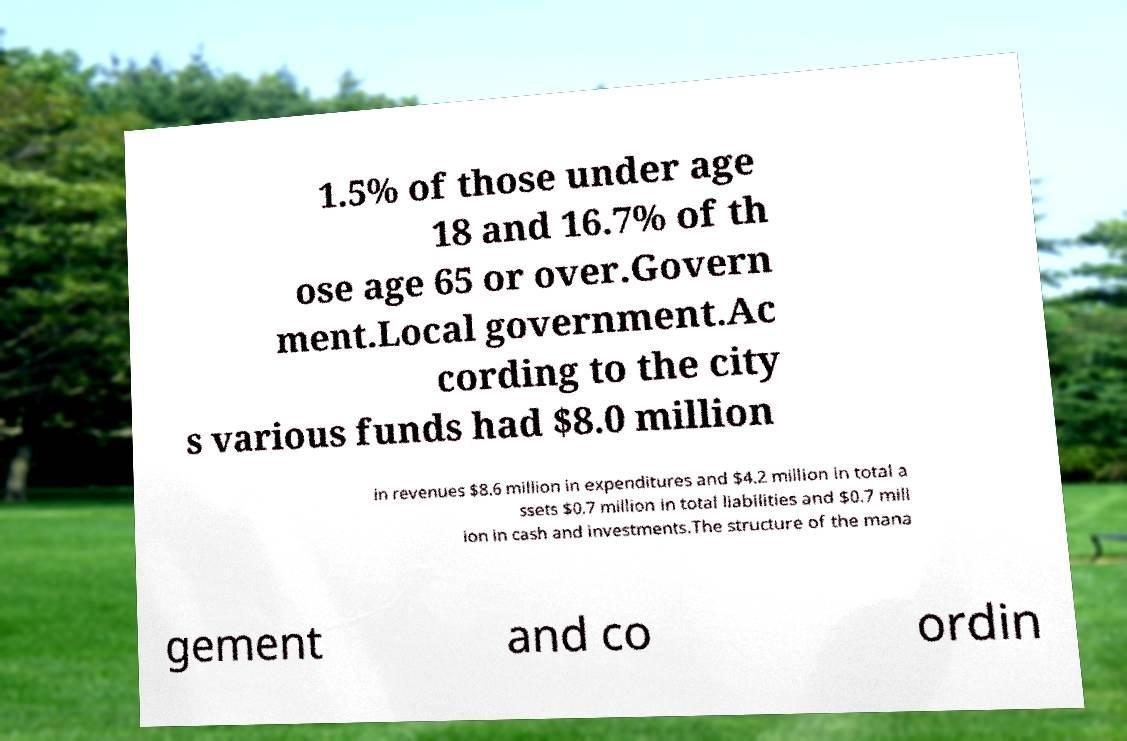Can you read and provide the text displayed in the image?This photo seems to have some interesting text. Can you extract and type it out for me? 1.5% of those under age 18 and 16.7% of th ose age 65 or over.Govern ment.Local government.Ac cording to the city s various funds had $8.0 million in revenues $8.6 million in expenditures and $4.2 million in total a ssets $0.7 million in total liabilities and $0.7 mill ion in cash and investments.The structure of the mana gement and co ordin 